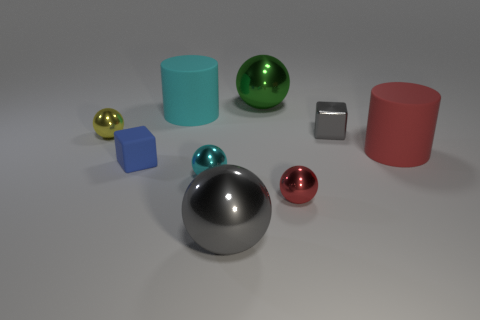Subtract all tiny yellow metal balls. How many balls are left? 4 Subtract all red cylinders. How many cylinders are left? 1 Subtract all cubes. How many objects are left? 7 Subtract all small gray things. Subtract all big matte objects. How many objects are left? 6 Add 7 metallic blocks. How many metallic blocks are left? 8 Add 8 green metal objects. How many green metal objects exist? 9 Subtract 1 cyan balls. How many objects are left? 8 Subtract all cyan cylinders. Subtract all yellow blocks. How many cylinders are left? 1 